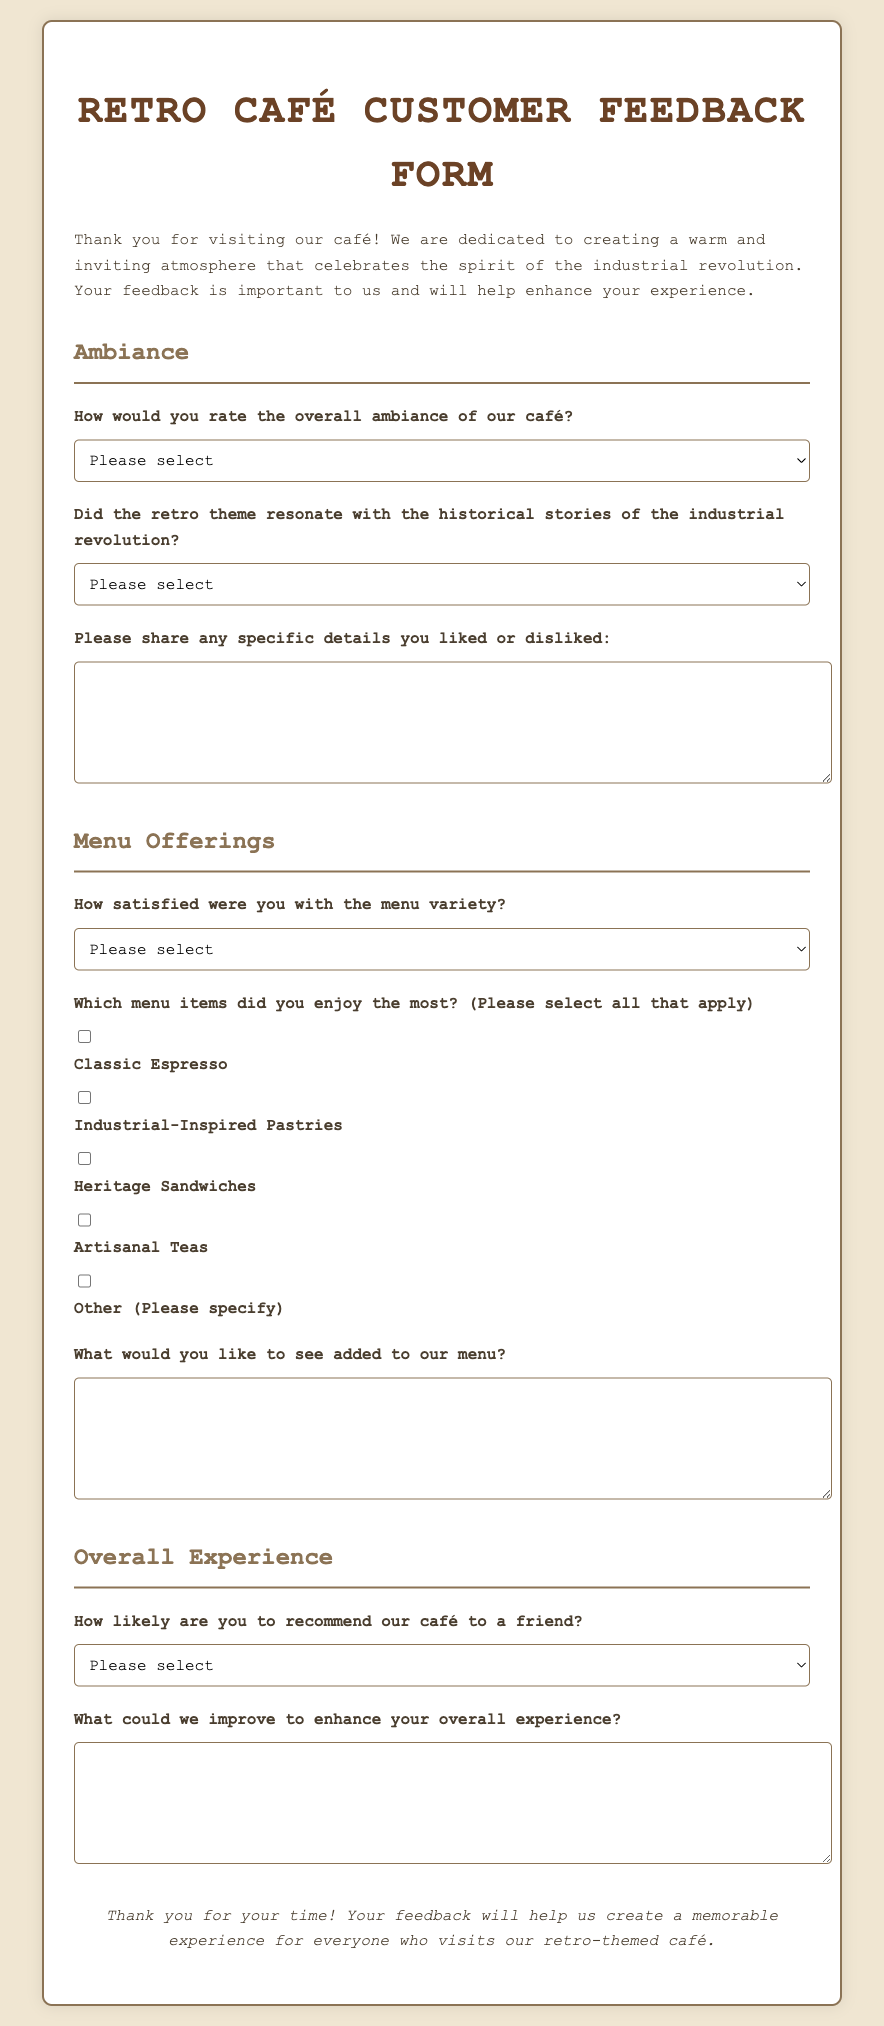How would you rate the overall ambiance of our café? This is one of the questions included in the feedback form that asks for the customer's rating of the café's ambiance.
Answer: Please select What theme does the café celebrate? The introductory paragraph mentions that the café celebrates the spirit of the industrial revolution, which is central to its theme.
Answer: Industrial revolution Which menu item options are presented in the form? The form lists items like Classic Espresso, Industrial-Inspired Pastries, Heritage Sandwiches, and Artisanal Teas.
Answer: Classic Espresso, Industrial-Inspired Pastries, Heritage Sandwiches, Artisanal Teas What feedback is requested about menu additions? The document contains a question that asks customers for suggestions on additional menu items they would like to see.
Answer: What would you like to see added to our menu? What is the primary purpose of the feedback form? The paragraph at the top clarifies that the form is used to gather customer feedback to enhance their experience.
Answer: Gather customer feedback 